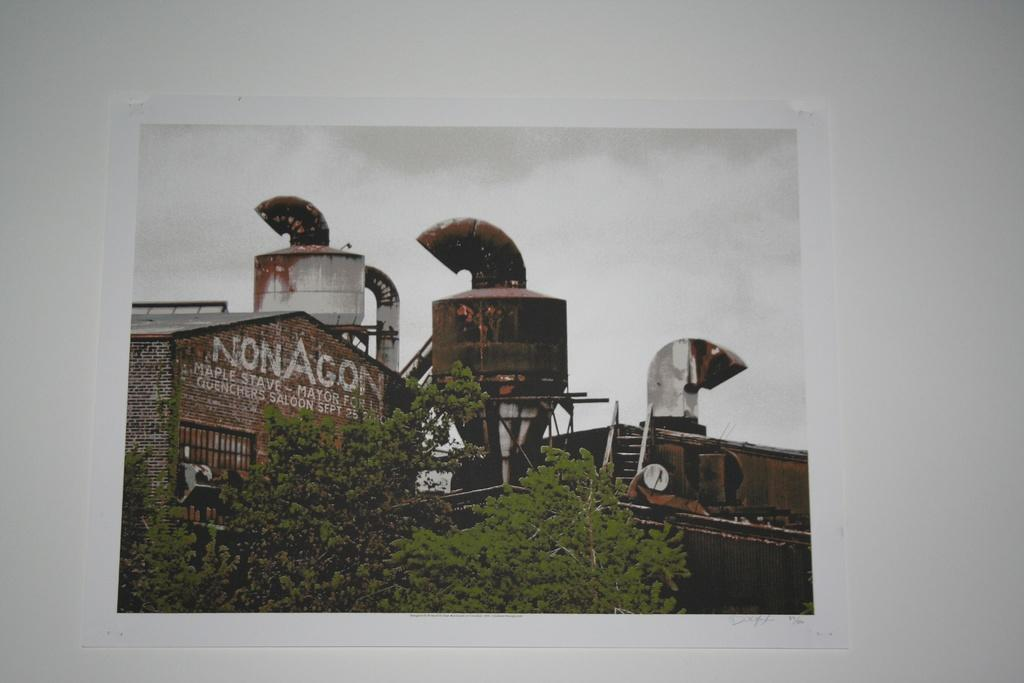<image>
Write a terse but informative summary of the picture. A brick building with the words Non Agon written on it. 